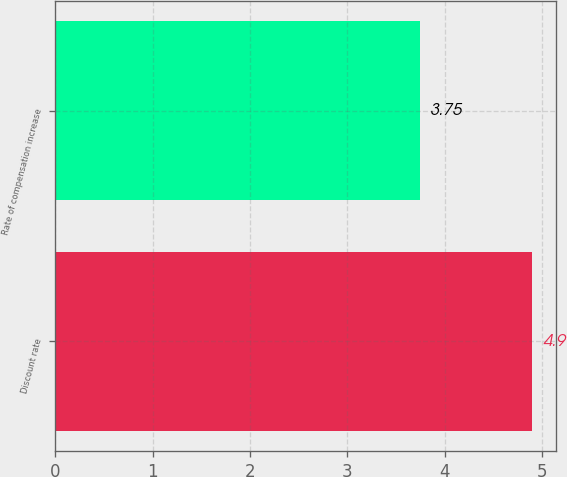<chart> <loc_0><loc_0><loc_500><loc_500><bar_chart><fcel>Discount rate<fcel>Rate of compensation increase<nl><fcel>4.9<fcel>3.75<nl></chart> 